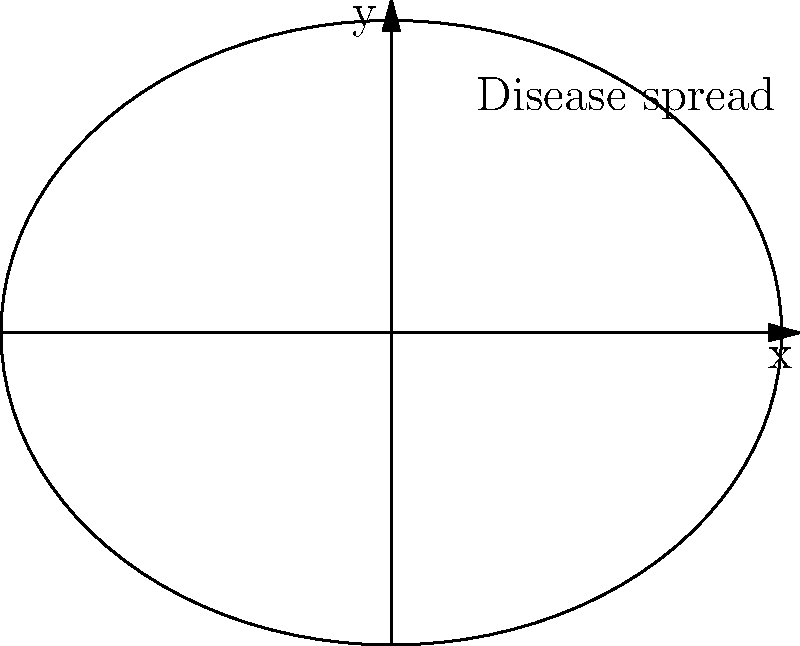A cattle disease outbreak is modeled using the parametric equations $x = 5\cos(t)$ and $y = 4\sin(t)$, where $x$ and $y$ represent the spread in kilometers along the east-west and north-south directions, respectively, and $t$ is time in days. What is the maximum east-west spread of the disease? To find the maximum east-west spread of the disease, we need to analyze the equation for $x$:

1) The equation for $x$ is $x = 5\cos(t)$

2) The cosine function oscillates between -1 and 1

3) Therefore, $5\cos(t)$ will oscillate between -5 and 5

4) The maximum positive value of $x$ is 5, and the minimum (maximum negative) value is -5

5) The total spread is the distance between these two extremes: $5 - (-5) = 10$

6) Therefore, the maximum east-west spread of the disease is 10 kilometers
Answer: 10 kilometers 